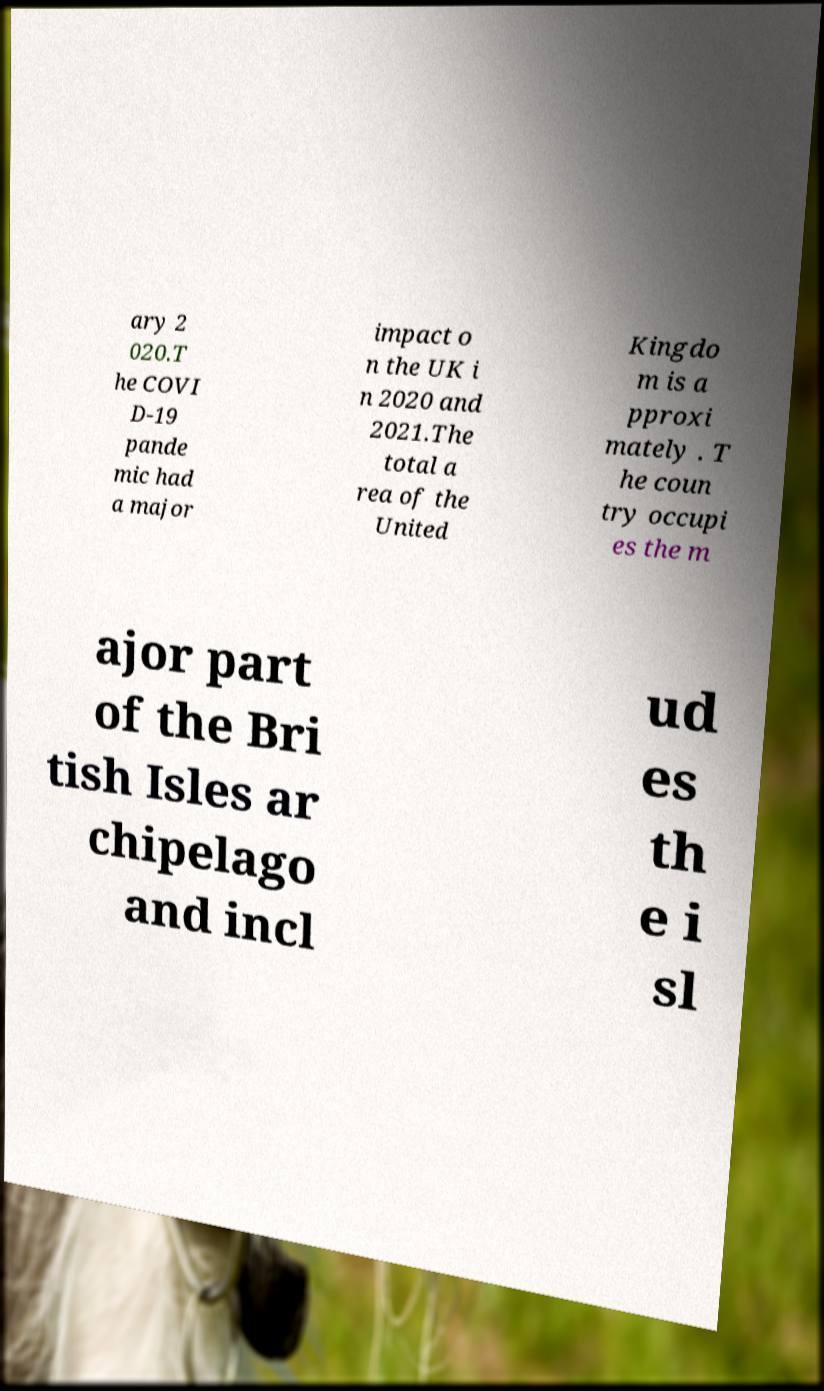For documentation purposes, I need the text within this image transcribed. Could you provide that? ary 2 020.T he COVI D-19 pande mic had a major impact o n the UK i n 2020 and 2021.The total a rea of the United Kingdo m is a pproxi mately . T he coun try occupi es the m ajor part of the Bri tish Isles ar chipelago and incl ud es th e i sl 